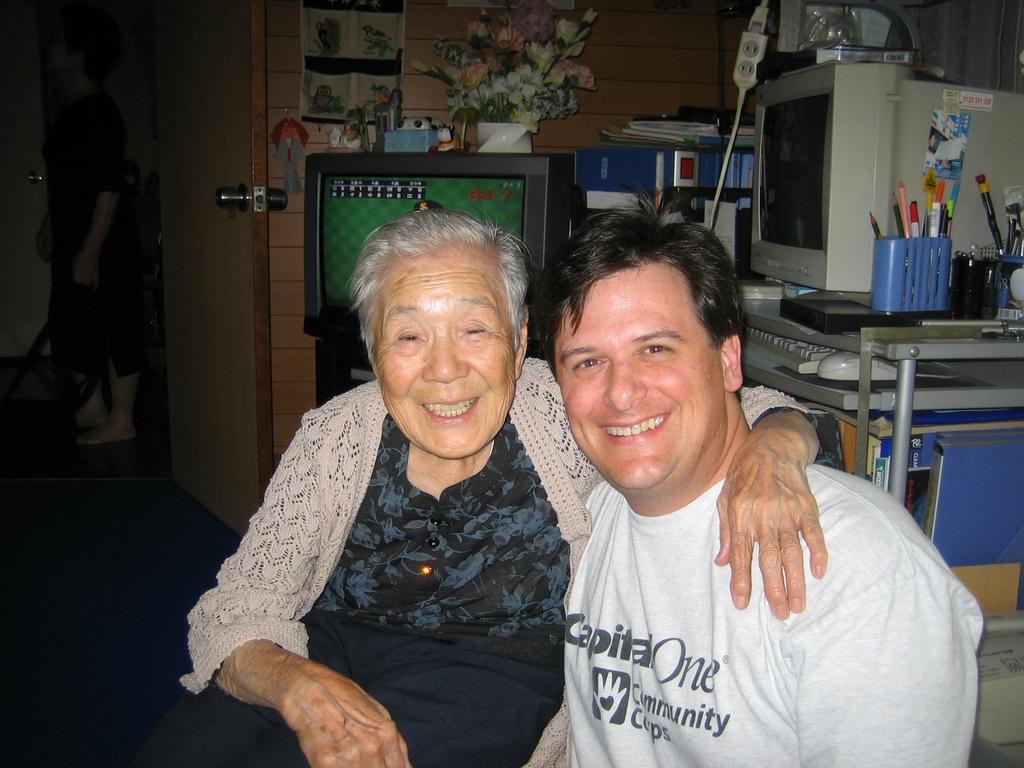How would you summarize this image in a sentence or two? In this image we can see three people, among them two people are sitting and smiling, and one person is standing, there are tables, on the tables, we can see television, monitor, pencils, pens and some other objects, on the television, we can see a flower vase and other objects, in the background we can see the wall. 